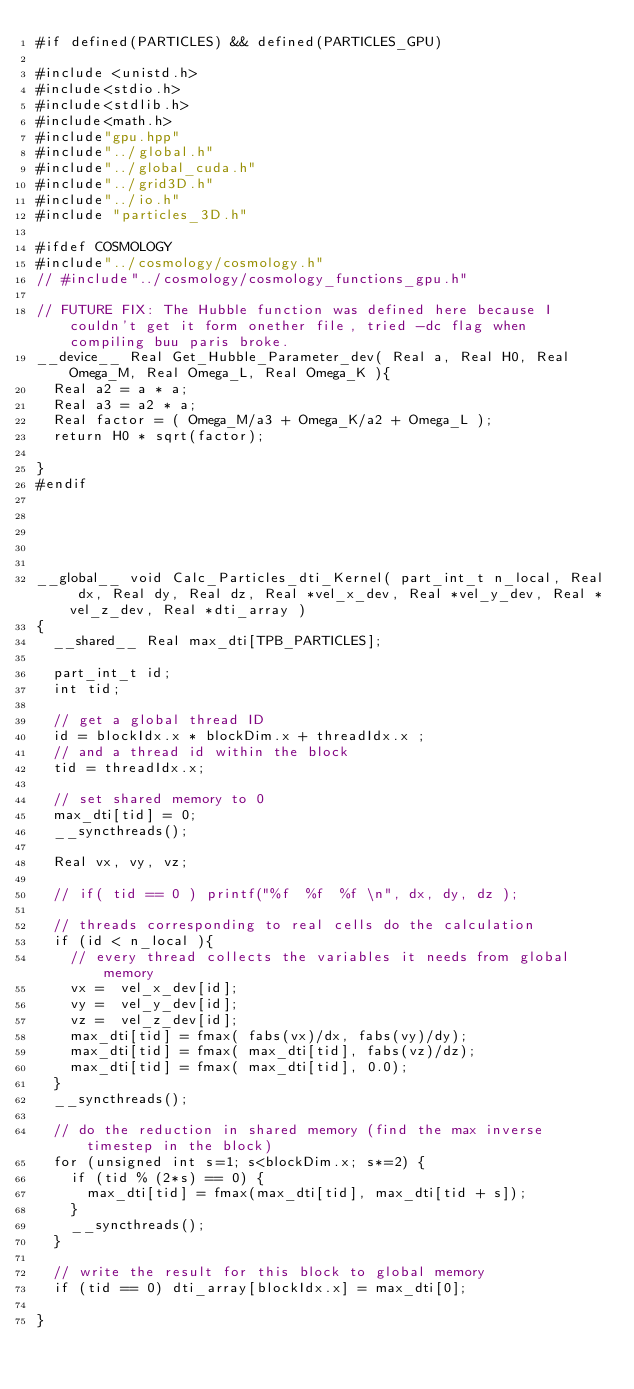Convert code to text. <code><loc_0><loc_0><loc_500><loc_500><_Cuda_>#if defined(PARTICLES) && defined(PARTICLES_GPU) 

#include <unistd.h>
#include<stdio.h>
#include<stdlib.h>
#include<math.h>
#include"gpu.hpp"
#include"../global.h"
#include"../global_cuda.h"
#include"../grid3D.h"
#include"../io.h"
#include "particles_3D.h"

#ifdef COSMOLOGY
#include"../cosmology/cosmology.h"
// #include"../cosmology/cosmology_functions_gpu.h"

// FUTURE FIX: The Hubble function was defined here because I couldn't get it form onether file, tried -dc flag when compiling buu paris broke. 
__device__ Real Get_Hubble_Parameter_dev( Real a, Real H0, Real Omega_M, Real Omega_L, Real Omega_K ){
  Real a2 = a * a;
  Real a3 = a2 * a;
  Real factor = ( Omega_M/a3 + Omega_K/a2 + Omega_L );
  return H0 * sqrt(factor);
  
}
#endif





__global__ void Calc_Particles_dti_Kernel( part_int_t n_local, Real dx, Real dy, Real dz, Real *vel_x_dev, Real *vel_y_dev, Real *vel_z_dev, Real *dti_array )
{  
  __shared__ Real max_dti[TPB_PARTICLES];
  
  part_int_t id;
  int tid;
   
  // get a global thread ID
  id = blockIdx.x * blockDim.x + threadIdx.x ;
  // and a thread id within the block  
  tid = threadIdx.x;
  
  // set shared memory to 0
  max_dti[tid] = 0;
  __syncthreads();
  
  Real vx, vy, vz;
  
  // if( tid == 0 ) printf("%f  %f  %f \n", dx, dy, dz );
  
  // threads corresponding to real cells do the calculation
  if (id < n_local ){
    // every thread collects the variables it needs from global memory
    vx =  vel_x_dev[id];
    vy =  vel_y_dev[id];
    vz =  vel_z_dev[id];
    max_dti[tid] = fmax( fabs(vx)/dx, fabs(vy)/dy);
    max_dti[tid] = fmax( max_dti[tid], fabs(vz)/dz);
    max_dti[tid] = fmax( max_dti[tid], 0.0);
  }
  __syncthreads();
  
  // do the reduction in shared memory (find the max inverse timestep in the block)
  for (unsigned int s=1; s<blockDim.x; s*=2) {
    if (tid % (2*s) == 0) {
      max_dti[tid] = fmax(max_dti[tid], max_dti[tid + s]);
    }
    __syncthreads();
  }
  
  // write the result for this block to global memory
  if (tid == 0) dti_array[blockIdx.x] = max_dti[0];

}




</code> 